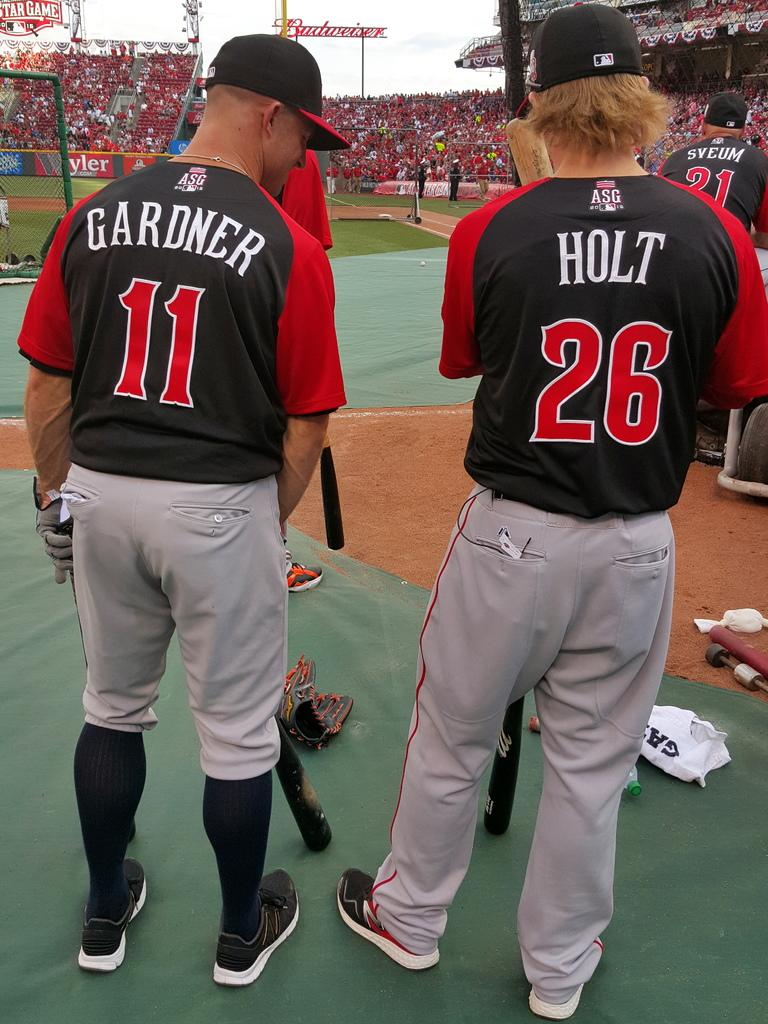Provide a one-sentence caption for the provided image. a person in a Gardner 11 shirt stands next to another in a Holt 26 shirt. 